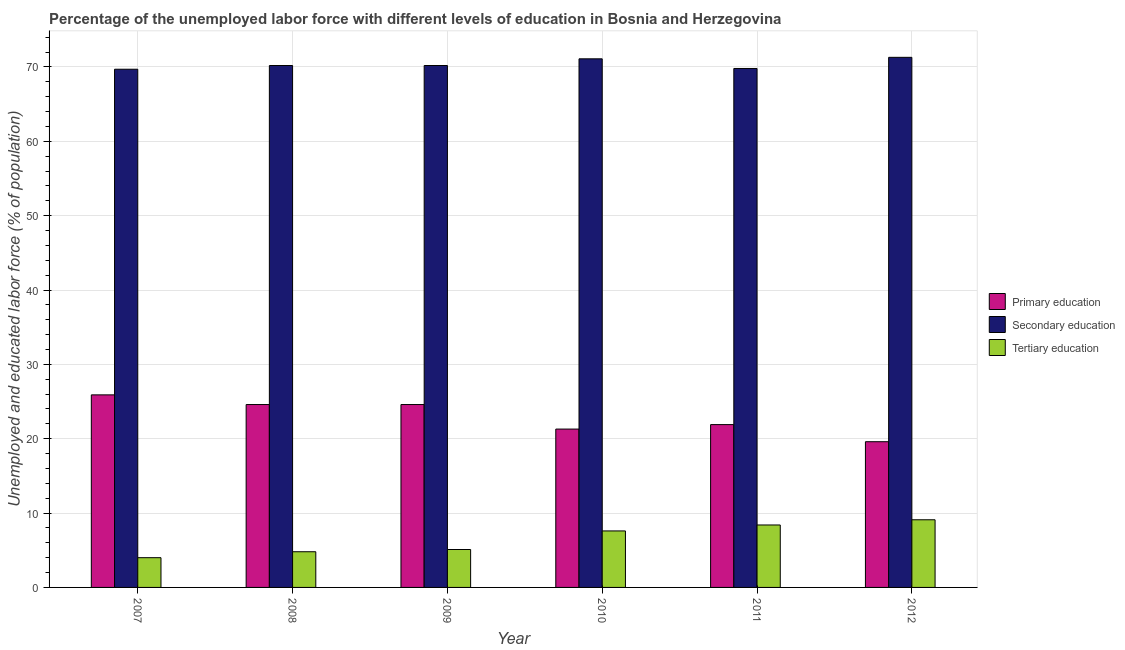How many different coloured bars are there?
Provide a succinct answer. 3. How many groups of bars are there?
Ensure brevity in your answer.  6. How many bars are there on the 5th tick from the right?
Offer a very short reply. 3. What is the label of the 1st group of bars from the left?
Make the answer very short. 2007. What is the percentage of labor force who received secondary education in 2011?
Your response must be concise. 69.8. Across all years, what is the maximum percentage of labor force who received primary education?
Your answer should be very brief. 25.9. Across all years, what is the minimum percentage of labor force who received secondary education?
Keep it short and to the point. 69.7. What is the total percentage of labor force who received primary education in the graph?
Your answer should be very brief. 137.9. What is the difference between the percentage of labor force who received primary education in 2008 and that in 2012?
Offer a very short reply. 5. What is the difference between the percentage of labor force who received tertiary education in 2007 and the percentage of labor force who received primary education in 2009?
Provide a short and direct response. -1.1. What is the average percentage of labor force who received secondary education per year?
Ensure brevity in your answer.  70.38. In how many years, is the percentage of labor force who received secondary education greater than 6 %?
Your response must be concise. 6. What is the ratio of the percentage of labor force who received primary education in 2009 to that in 2012?
Make the answer very short. 1.26. Is the difference between the percentage of labor force who received primary education in 2008 and 2010 greater than the difference between the percentage of labor force who received secondary education in 2008 and 2010?
Give a very brief answer. No. What is the difference between the highest and the second highest percentage of labor force who received tertiary education?
Offer a terse response. 0.7. What is the difference between the highest and the lowest percentage of labor force who received primary education?
Make the answer very short. 6.3. In how many years, is the percentage of labor force who received primary education greater than the average percentage of labor force who received primary education taken over all years?
Your answer should be compact. 3. What does the 2nd bar from the left in 2011 represents?
Your response must be concise. Secondary education. What does the 2nd bar from the right in 2007 represents?
Keep it short and to the point. Secondary education. Is it the case that in every year, the sum of the percentage of labor force who received primary education and percentage of labor force who received secondary education is greater than the percentage of labor force who received tertiary education?
Give a very brief answer. Yes. What is the difference between two consecutive major ticks on the Y-axis?
Offer a terse response. 10. Does the graph contain any zero values?
Provide a succinct answer. No. Where does the legend appear in the graph?
Your response must be concise. Center right. How are the legend labels stacked?
Offer a very short reply. Vertical. What is the title of the graph?
Your answer should be very brief. Percentage of the unemployed labor force with different levels of education in Bosnia and Herzegovina. Does "Nuclear sources" appear as one of the legend labels in the graph?
Your response must be concise. No. What is the label or title of the Y-axis?
Offer a terse response. Unemployed and educated labor force (% of population). What is the Unemployed and educated labor force (% of population) in Primary education in 2007?
Your response must be concise. 25.9. What is the Unemployed and educated labor force (% of population) in Secondary education in 2007?
Provide a succinct answer. 69.7. What is the Unemployed and educated labor force (% of population) in Primary education in 2008?
Make the answer very short. 24.6. What is the Unemployed and educated labor force (% of population) of Secondary education in 2008?
Ensure brevity in your answer.  70.2. What is the Unemployed and educated labor force (% of population) in Tertiary education in 2008?
Your answer should be very brief. 4.8. What is the Unemployed and educated labor force (% of population) of Primary education in 2009?
Your answer should be compact. 24.6. What is the Unemployed and educated labor force (% of population) in Secondary education in 2009?
Your response must be concise. 70.2. What is the Unemployed and educated labor force (% of population) of Tertiary education in 2009?
Your answer should be compact. 5.1. What is the Unemployed and educated labor force (% of population) in Primary education in 2010?
Make the answer very short. 21.3. What is the Unemployed and educated labor force (% of population) in Secondary education in 2010?
Make the answer very short. 71.1. What is the Unemployed and educated labor force (% of population) in Tertiary education in 2010?
Ensure brevity in your answer.  7.6. What is the Unemployed and educated labor force (% of population) in Primary education in 2011?
Your answer should be compact. 21.9. What is the Unemployed and educated labor force (% of population) of Secondary education in 2011?
Keep it short and to the point. 69.8. What is the Unemployed and educated labor force (% of population) in Tertiary education in 2011?
Give a very brief answer. 8.4. What is the Unemployed and educated labor force (% of population) in Primary education in 2012?
Provide a succinct answer. 19.6. What is the Unemployed and educated labor force (% of population) in Secondary education in 2012?
Ensure brevity in your answer.  71.3. What is the Unemployed and educated labor force (% of population) in Tertiary education in 2012?
Your answer should be compact. 9.1. Across all years, what is the maximum Unemployed and educated labor force (% of population) of Primary education?
Provide a succinct answer. 25.9. Across all years, what is the maximum Unemployed and educated labor force (% of population) of Secondary education?
Your response must be concise. 71.3. Across all years, what is the maximum Unemployed and educated labor force (% of population) of Tertiary education?
Your response must be concise. 9.1. Across all years, what is the minimum Unemployed and educated labor force (% of population) in Primary education?
Offer a very short reply. 19.6. Across all years, what is the minimum Unemployed and educated labor force (% of population) of Secondary education?
Provide a short and direct response. 69.7. Across all years, what is the minimum Unemployed and educated labor force (% of population) in Tertiary education?
Give a very brief answer. 4. What is the total Unemployed and educated labor force (% of population) of Primary education in the graph?
Make the answer very short. 137.9. What is the total Unemployed and educated labor force (% of population) of Secondary education in the graph?
Make the answer very short. 422.3. What is the difference between the Unemployed and educated labor force (% of population) in Primary education in 2007 and that in 2008?
Offer a very short reply. 1.3. What is the difference between the Unemployed and educated labor force (% of population) of Tertiary education in 2007 and that in 2008?
Give a very brief answer. -0.8. What is the difference between the Unemployed and educated labor force (% of population) of Tertiary education in 2007 and that in 2010?
Keep it short and to the point. -3.6. What is the difference between the Unemployed and educated labor force (% of population) in Primary education in 2007 and that in 2011?
Offer a terse response. 4. What is the difference between the Unemployed and educated labor force (% of population) in Tertiary education in 2007 and that in 2011?
Your response must be concise. -4.4. What is the difference between the Unemployed and educated labor force (% of population) in Primary education in 2007 and that in 2012?
Keep it short and to the point. 6.3. What is the difference between the Unemployed and educated labor force (% of population) in Tertiary education in 2007 and that in 2012?
Your answer should be very brief. -5.1. What is the difference between the Unemployed and educated labor force (% of population) in Primary education in 2008 and that in 2010?
Provide a succinct answer. 3.3. What is the difference between the Unemployed and educated labor force (% of population) in Primary education in 2008 and that in 2011?
Ensure brevity in your answer.  2.7. What is the difference between the Unemployed and educated labor force (% of population) of Secondary education in 2008 and that in 2011?
Offer a terse response. 0.4. What is the difference between the Unemployed and educated labor force (% of population) in Tertiary education in 2008 and that in 2011?
Provide a short and direct response. -3.6. What is the difference between the Unemployed and educated labor force (% of population) in Primary education in 2009 and that in 2010?
Ensure brevity in your answer.  3.3. What is the difference between the Unemployed and educated labor force (% of population) of Primary education in 2009 and that in 2011?
Make the answer very short. 2.7. What is the difference between the Unemployed and educated labor force (% of population) of Secondary education in 2009 and that in 2011?
Offer a terse response. 0.4. What is the difference between the Unemployed and educated labor force (% of population) of Primary education in 2009 and that in 2012?
Provide a succinct answer. 5. What is the difference between the Unemployed and educated labor force (% of population) of Tertiary education in 2009 and that in 2012?
Provide a succinct answer. -4. What is the difference between the Unemployed and educated labor force (% of population) of Secondary education in 2010 and that in 2011?
Make the answer very short. 1.3. What is the difference between the Unemployed and educated labor force (% of population) in Tertiary education in 2010 and that in 2011?
Provide a succinct answer. -0.8. What is the difference between the Unemployed and educated labor force (% of population) in Primary education in 2010 and that in 2012?
Give a very brief answer. 1.7. What is the difference between the Unemployed and educated labor force (% of population) in Secondary education in 2010 and that in 2012?
Make the answer very short. -0.2. What is the difference between the Unemployed and educated labor force (% of population) of Secondary education in 2011 and that in 2012?
Keep it short and to the point. -1.5. What is the difference between the Unemployed and educated labor force (% of population) of Tertiary education in 2011 and that in 2012?
Your answer should be very brief. -0.7. What is the difference between the Unemployed and educated labor force (% of population) of Primary education in 2007 and the Unemployed and educated labor force (% of population) of Secondary education in 2008?
Provide a short and direct response. -44.3. What is the difference between the Unemployed and educated labor force (% of population) in Primary education in 2007 and the Unemployed and educated labor force (% of population) in Tertiary education in 2008?
Make the answer very short. 21.1. What is the difference between the Unemployed and educated labor force (% of population) in Secondary education in 2007 and the Unemployed and educated labor force (% of population) in Tertiary education in 2008?
Make the answer very short. 64.9. What is the difference between the Unemployed and educated labor force (% of population) in Primary education in 2007 and the Unemployed and educated labor force (% of population) in Secondary education in 2009?
Make the answer very short. -44.3. What is the difference between the Unemployed and educated labor force (% of population) in Primary education in 2007 and the Unemployed and educated labor force (% of population) in Tertiary education in 2009?
Keep it short and to the point. 20.8. What is the difference between the Unemployed and educated labor force (% of population) in Secondary education in 2007 and the Unemployed and educated labor force (% of population) in Tertiary education in 2009?
Provide a short and direct response. 64.6. What is the difference between the Unemployed and educated labor force (% of population) of Primary education in 2007 and the Unemployed and educated labor force (% of population) of Secondary education in 2010?
Make the answer very short. -45.2. What is the difference between the Unemployed and educated labor force (% of population) in Secondary education in 2007 and the Unemployed and educated labor force (% of population) in Tertiary education in 2010?
Your answer should be very brief. 62.1. What is the difference between the Unemployed and educated labor force (% of population) in Primary education in 2007 and the Unemployed and educated labor force (% of population) in Secondary education in 2011?
Offer a very short reply. -43.9. What is the difference between the Unemployed and educated labor force (% of population) of Secondary education in 2007 and the Unemployed and educated labor force (% of population) of Tertiary education in 2011?
Ensure brevity in your answer.  61.3. What is the difference between the Unemployed and educated labor force (% of population) in Primary education in 2007 and the Unemployed and educated labor force (% of population) in Secondary education in 2012?
Your response must be concise. -45.4. What is the difference between the Unemployed and educated labor force (% of population) of Primary education in 2007 and the Unemployed and educated labor force (% of population) of Tertiary education in 2012?
Provide a short and direct response. 16.8. What is the difference between the Unemployed and educated labor force (% of population) of Secondary education in 2007 and the Unemployed and educated labor force (% of population) of Tertiary education in 2012?
Offer a very short reply. 60.6. What is the difference between the Unemployed and educated labor force (% of population) of Primary education in 2008 and the Unemployed and educated labor force (% of population) of Secondary education in 2009?
Provide a succinct answer. -45.6. What is the difference between the Unemployed and educated labor force (% of population) of Secondary education in 2008 and the Unemployed and educated labor force (% of population) of Tertiary education in 2009?
Offer a terse response. 65.1. What is the difference between the Unemployed and educated labor force (% of population) of Primary education in 2008 and the Unemployed and educated labor force (% of population) of Secondary education in 2010?
Your answer should be compact. -46.5. What is the difference between the Unemployed and educated labor force (% of population) of Secondary education in 2008 and the Unemployed and educated labor force (% of population) of Tertiary education in 2010?
Give a very brief answer. 62.6. What is the difference between the Unemployed and educated labor force (% of population) of Primary education in 2008 and the Unemployed and educated labor force (% of population) of Secondary education in 2011?
Offer a very short reply. -45.2. What is the difference between the Unemployed and educated labor force (% of population) of Primary education in 2008 and the Unemployed and educated labor force (% of population) of Tertiary education in 2011?
Ensure brevity in your answer.  16.2. What is the difference between the Unemployed and educated labor force (% of population) of Secondary education in 2008 and the Unemployed and educated labor force (% of population) of Tertiary education in 2011?
Offer a terse response. 61.8. What is the difference between the Unemployed and educated labor force (% of population) in Primary education in 2008 and the Unemployed and educated labor force (% of population) in Secondary education in 2012?
Ensure brevity in your answer.  -46.7. What is the difference between the Unemployed and educated labor force (% of population) of Secondary education in 2008 and the Unemployed and educated labor force (% of population) of Tertiary education in 2012?
Your response must be concise. 61.1. What is the difference between the Unemployed and educated labor force (% of population) in Primary education in 2009 and the Unemployed and educated labor force (% of population) in Secondary education in 2010?
Offer a very short reply. -46.5. What is the difference between the Unemployed and educated labor force (% of population) in Primary education in 2009 and the Unemployed and educated labor force (% of population) in Tertiary education in 2010?
Your response must be concise. 17. What is the difference between the Unemployed and educated labor force (% of population) in Secondary education in 2009 and the Unemployed and educated labor force (% of population) in Tertiary education in 2010?
Your answer should be very brief. 62.6. What is the difference between the Unemployed and educated labor force (% of population) in Primary education in 2009 and the Unemployed and educated labor force (% of population) in Secondary education in 2011?
Keep it short and to the point. -45.2. What is the difference between the Unemployed and educated labor force (% of population) of Secondary education in 2009 and the Unemployed and educated labor force (% of population) of Tertiary education in 2011?
Your answer should be compact. 61.8. What is the difference between the Unemployed and educated labor force (% of population) in Primary education in 2009 and the Unemployed and educated labor force (% of population) in Secondary education in 2012?
Your answer should be very brief. -46.7. What is the difference between the Unemployed and educated labor force (% of population) of Secondary education in 2009 and the Unemployed and educated labor force (% of population) of Tertiary education in 2012?
Your answer should be very brief. 61.1. What is the difference between the Unemployed and educated labor force (% of population) of Primary education in 2010 and the Unemployed and educated labor force (% of population) of Secondary education in 2011?
Ensure brevity in your answer.  -48.5. What is the difference between the Unemployed and educated labor force (% of population) in Secondary education in 2010 and the Unemployed and educated labor force (% of population) in Tertiary education in 2011?
Your answer should be compact. 62.7. What is the difference between the Unemployed and educated labor force (% of population) of Primary education in 2010 and the Unemployed and educated labor force (% of population) of Secondary education in 2012?
Provide a succinct answer. -50. What is the difference between the Unemployed and educated labor force (% of population) of Secondary education in 2010 and the Unemployed and educated labor force (% of population) of Tertiary education in 2012?
Your answer should be compact. 62. What is the difference between the Unemployed and educated labor force (% of population) of Primary education in 2011 and the Unemployed and educated labor force (% of population) of Secondary education in 2012?
Your response must be concise. -49.4. What is the difference between the Unemployed and educated labor force (% of population) in Secondary education in 2011 and the Unemployed and educated labor force (% of population) in Tertiary education in 2012?
Your answer should be very brief. 60.7. What is the average Unemployed and educated labor force (% of population) of Primary education per year?
Provide a succinct answer. 22.98. What is the average Unemployed and educated labor force (% of population) of Secondary education per year?
Offer a terse response. 70.38. In the year 2007, what is the difference between the Unemployed and educated labor force (% of population) of Primary education and Unemployed and educated labor force (% of population) of Secondary education?
Provide a short and direct response. -43.8. In the year 2007, what is the difference between the Unemployed and educated labor force (% of population) of Primary education and Unemployed and educated labor force (% of population) of Tertiary education?
Your response must be concise. 21.9. In the year 2007, what is the difference between the Unemployed and educated labor force (% of population) in Secondary education and Unemployed and educated labor force (% of population) in Tertiary education?
Provide a succinct answer. 65.7. In the year 2008, what is the difference between the Unemployed and educated labor force (% of population) of Primary education and Unemployed and educated labor force (% of population) of Secondary education?
Provide a succinct answer. -45.6. In the year 2008, what is the difference between the Unemployed and educated labor force (% of population) in Primary education and Unemployed and educated labor force (% of population) in Tertiary education?
Provide a short and direct response. 19.8. In the year 2008, what is the difference between the Unemployed and educated labor force (% of population) in Secondary education and Unemployed and educated labor force (% of population) in Tertiary education?
Offer a very short reply. 65.4. In the year 2009, what is the difference between the Unemployed and educated labor force (% of population) in Primary education and Unemployed and educated labor force (% of population) in Secondary education?
Offer a very short reply. -45.6. In the year 2009, what is the difference between the Unemployed and educated labor force (% of population) of Primary education and Unemployed and educated labor force (% of population) of Tertiary education?
Keep it short and to the point. 19.5. In the year 2009, what is the difference between the Unemployed and educated labor force (% of population) of Secondary education and Unemployed and educated labor force (% of population) of Tertiary education?
Your answer should be compact. 65.1. In the year 2010, what is the difference between the Unemployed and educated labor force (% of population) in Primary education and Unemployed and educated labor force (% of population) in Secondary education?
Give a very brief answer. -49.8. In the year 2010, what is the difference between the Unemployed and educated labor force (% of population) of Secondary education and Unemployed and educated labor force (% of population) of Tertiary education?
Make the answer very short. 63.5. In the year 2011, what is the difference between the Unemployed and educated labor force (% of population) in Primary education and Unemployed and educated labor force (% of population) in Secondary education?
Offer a very short reply. -47.9. In the year 2011, what is the difference between the Unemployed and educated labor force (% of population) in Primary education and Unemployed and educated labor force (% of population) in Tertiary education?
Offer a very short reply. 13.5. In the year 2011, what is the difference between the Unemployed and educated labor force (% of population) in Secondary education and Unemployed and educated labor force (% of population) in Tertiary education?
Give a very brief answer. 61.4. In the year 2012, what is the difference between the Unemployed and educated labor force (% of population) in Primary education and Unemployed and educated labor force (% of population) in Secondary education?
Provide a succinct answer. -51.7. In the year 2012, what is the difference between the Unemployed and educated labor force (% of population) in Secondary education and Unemployed and educated labor force (% of population) in Tertiary education?
Ensure brevity in your answer.  62.2. What is the ratio of the Unemployed and educated labor force (% of population) in Primary education in 2007 to that in 2008?
Provide a short and direct response. 1.05. What is the ratio of the Unemployed and educated labor force (% of population) in Primary education in 2007 to that in 2009?
Your answer should be very brief. 1.05. What is the ratio of the Unemployed and educated labor force (% of population) in Tertiary education in 2007 to that in 2009?
Provide a short and direct response. 0.78. What is the ratio of the Unemployed and educated labor force (% of population) of Primary education in 2007 to that in 2010?
Ensure brevity in your answer.  1.22. What is the ratio of the Unemployed and educated labor force (% of population) in Secondary education in 2007 to that in 2010?
Your response must be concise. 0.98. What is the ratio of the Unemployed and educated labor force (% of population) in Tertiary education in 2007 to that in 2010?
Your response must be concise. 0.53. What is the ratio of the Unemployed and educated labor force (% of population) in Primary education in 2007 to that in 2011?
Give a very brief answer. 1.18. What is the ratio of the Unemployed and educated labor force (% of population) in Tertiary education in 2007 to that in 2011?
Your answer should be very brief. 0.48. What is the ratio of the Unemployed and educated labor force (% of population) in Primary education in 2007 to that in 2012?
Offer a terse response. 1.32. What is the ratio of the Unemployed and educated labor force (% of population) in Secondary education in 2007 to that in 2012?
Offer a very short reply. 0.98. What is the ratio of the Unemployed and educated labor force (% of population) of Tertiary education in 2007 to that in 2012?
Provide a short and direct response. 0.44. What is the ratio of the Unemployed and educated labor force (% of population) in Tertiary education in 2008 to that in 2009?
Offer a very short reply. 0.94. What is the ratio of the Unemployed and educated labor force (% of population) in Primary education in 2008 to that in 2010?
Your response must be concise. 1.15. What is the ratio of the Unemployed and educated labor force (% of population) of Secondary education in 2008 to that in 2010?
Make the answer very short. 0.99. What is the ratio of the Unemployed and educated labor force (% of population) of Tertiary education in 2008 to that in 2010?
Offer a terse response. 0.63. What is the ratio of the Unemployed and educated labor force (% of population) of Primary education in 2008 to that in 2011?
Provide a short and direct response. 1.12. What is the ratio of the Unemployed and educated labor force (% of population) of Secondary education in 2008 to that in 2011?
Ensure brevity in your answer.  1.01. What is the ratio of the Unemployed and educated labor force (% of population) in Tertiary education in 2008 to that in 2011?
Keep it short and to the point. 0.57. What is the ratio of the Unemployed and educated labor force (% of population) of Primary education in 2008 to that in 2012?
Give a very brief answer. 1.26. What is the ratio of the Unemployed and educated labor force (% of population) in Secondary education in 2008 to that in 2012?
Your answer should be very brief. 0.98. What is the ratio of the Unemployed and educated labor force (% of population) in Tertiary education in 2008 to that in 2012?
Ensure brevity in your answer.  0.53. What is the ratio of the Unemployed and educated labor force (% of population) of Primary education in 2009 to that in 2010?
Offer a very short reply. 1.15. What is the ratio of the Unemployed and educated labor force (% of population) of Secondary education in 2009 to that in 2010?
Make the answer very short. 0.99. What is the ratio of the Unemployed and educated labor force (% of population) of Tertiary education in 2009 to that in 2010?
Ensure brevity in your answer.  0.67. What is the ratio of the Unemployed and educated labor force (% of population) of Primary education in 2009 to that in 2011?
Offer a terse response. 1.12. What is the ratio of the Unemployed and educated labor force (% of population) in Tertiary education in 2009 to that in 2011?
Your answer should be compact. 0.61. What is the ratio of the Unemployed and educated labor force (% of population) of Primary education in 2009 to that in 2012?
Your answer should be compact. 1.26. What is the ratio of the Unemployed and educated labor force (% of population) of Secondary education in 2009 to that in 2012?
Make the answer very short. 0.98. What is the ratio of the Unemployed and educated labor force (% of population) in Tertiary education in 2009 to that in 2012?
Your answer should be very brief. 0.56. What is the ratio of the Unemployed and educated labor force (% of population) in Primary education in 2010 to that in 2011?
Provide a succinct answer. 0.97. What is the ratio of the Unemployed and educated labor force (% of population) in Secondary education in 2010 to that in 2011?
Make the answer very short. 1.02. What is the ratio of the Unemployed and educated labor force (% of population) of Tertiary education in 2010 to that in 2011?
Ensure brevity in your answer.  0.9. What is the ratio of the Unemployed and educated labor force (% of population) in Primary education in 2010 to that in 2012?
Your response must be concise. 1.09. What is the ratio of the Unemployed and educated labor force (% of population) in Tertiary education in 2010 to that in 2012?
Your answer should be compact. 0.84. What is the ratio of the Unemployed and educated labor force (% of population) in Primary education in 2011 to that in 2012?
Your answer should be very brief. 1.12. What is the difference between the highest and the second highest Unemployed and educated labor force (% of population) in Secondary education?
Offer a terse response. 0.2. What is the difference between the highest and the second highest Unemployed and educated labor force (% of population) in Tertiary education?
Give a very brief answer. 0.7. What is the difference between the highest and the lowest Unemployed and educated labor force (% of population) in Primary education?
Your answer should be compact. 6.3. What is the difference between the highest and the lowest Unemployed and educated labor force (% of population) in Tertiary education?
Offer a terse response. 5.1. 